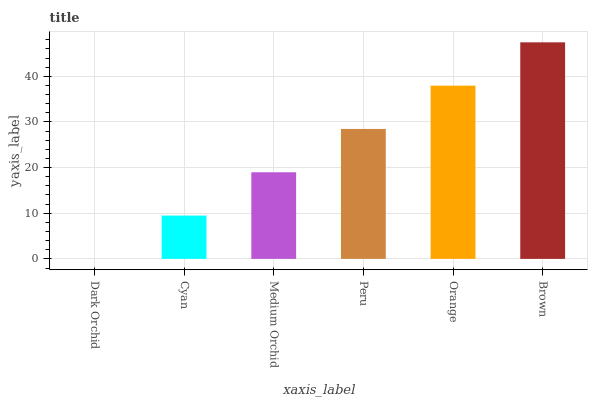Is Dark Orchid the minimum?
Answer yes or no. Yes. Is Brown the maximum?
Answer yes or no. Yes. Is Cyan the minimum?
Answer yes or no. No. Is Cyan the maximum?
Answer yes or no. No. Is Cyan greater than Dark Orchid?
Answer yes or no. Yes. Is Dark Orchid less than Cyan?
Answer yes or no. Yes. Is Dark Orchid greater than Cyan?
Answer yes or no. No. Is Cyan less than Dark Orchid?
Answer yes or no. No. Is Peru the high median?
Answer yes or no. Yes. Is Medium Orchid the low median?
Answer yes or no. Yes. Is Medium Orchid the high median?
Answer yes or no. No. Is Orange the low median?
Answer yes or no. No. 